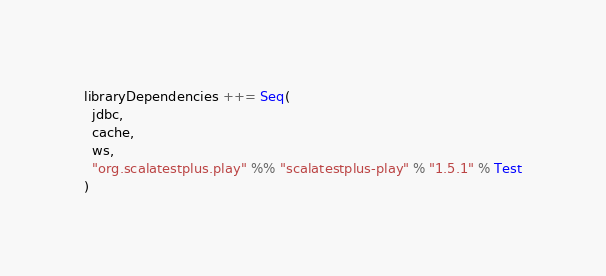<code> <loc_0><loc_0><loc_500><loc_500><_Scala_>
libraryDependencies ++= Seq(
  jdbc,
  cache,
  ws,
  "org.scalatestplus.play" %% "scalatestplus-play" % "1.5.1" % Test
)

</code> 